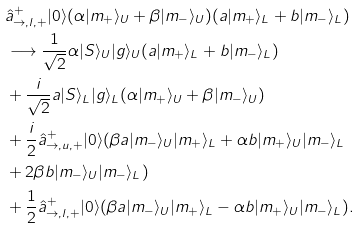Convert formula to latex. <formula><loc_0><loc_0><loc_500><loc_500>& \hat { a } _ { \rightarrow , l , + } ^ { + } | 0 \rangle ( \alpha | m _ { + } \rangle _ { U } + \beta | m _ { - } \rangle _ { U } ) ( a | m _ { + } \rangle _ { L } + b | m _ { - } \rangle _ { L } ) \\ & \longrightarrow \frac { 1 } { \sqrt { 2 } } \alpha | S \rangle _ { U } | g \rangle _ { U } ( a | m _ { + } \rangle _ { L } + b | m _ { - } \rangle _ { L } ) \\ & + \frac { i } { \sqrt { 2 } } a | S \rangle _ { L } | g \rangle _ { L } ( \alpha | m _ { + } \rangle _ { U } + \beta | m _ { - } \rangle _ { U } ) \\ & + \frac { i } { 2 } \hat { a } _ { \rightarrow , u , + } ^ { + } | 0 \rangle ( \beta { a } | m _ { - } \rangle _ { U } | m _ { + } \rangle _ { L } + \alpha { b } | m _ { + } \rangle _ { U } | m _ { - } \rangle _ { L } \\ & + 2 \beta { b } | m _ { - } \rangle _ { U } | m _ { - } \rangle _ { L } ) \\ & + \frac { 1 } { 2 } \hat { a } _ { \rightarrow , l , + } ^ { + } | 0 \rangle ( \beta { a } | m _ { - } \rangle _ { U } | m _ { + } \rangle _ { L } - \alpha { b } | m _ { + } \rangle _ { U } | m _ { - } \rangle _ { L } ) .</formula> 